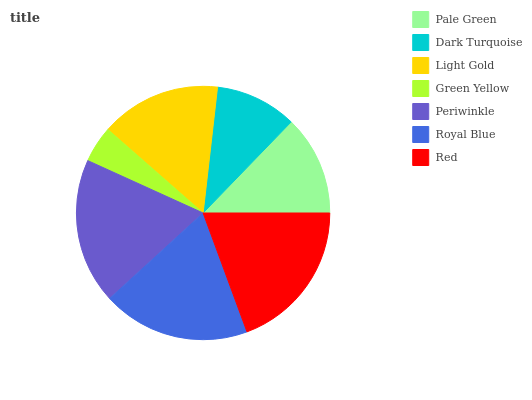Is Green Yellow the minimum?
Answer yes or no. Yes. Is Red the maximum?
Answer yes or no. Yes. Is Dark Turquoise the minimum?
Answer yes or no. No. Is Dark Turquoise the maximum?
Answer yes or no. No. Is Pale Green greater than Dark Turquoise?
Answer yes or no. Yes. Is Dark Turquoise less than Pale Green?
Answer yes or no. Yes. Is Dark Turquoise greater than Pale Green?
Answer yes or no. No. Is Pale Green less than Dark Turquoise?
Answer yes or no. No. Is Light Gold the high median?
Answer yes or no. Yes. Is Light Gold the low median?
Answer yes or no. Yes. Is Pale Green the high median?
Answer yes or no. No. Is Red the low median?
Answer yes or no. No. 